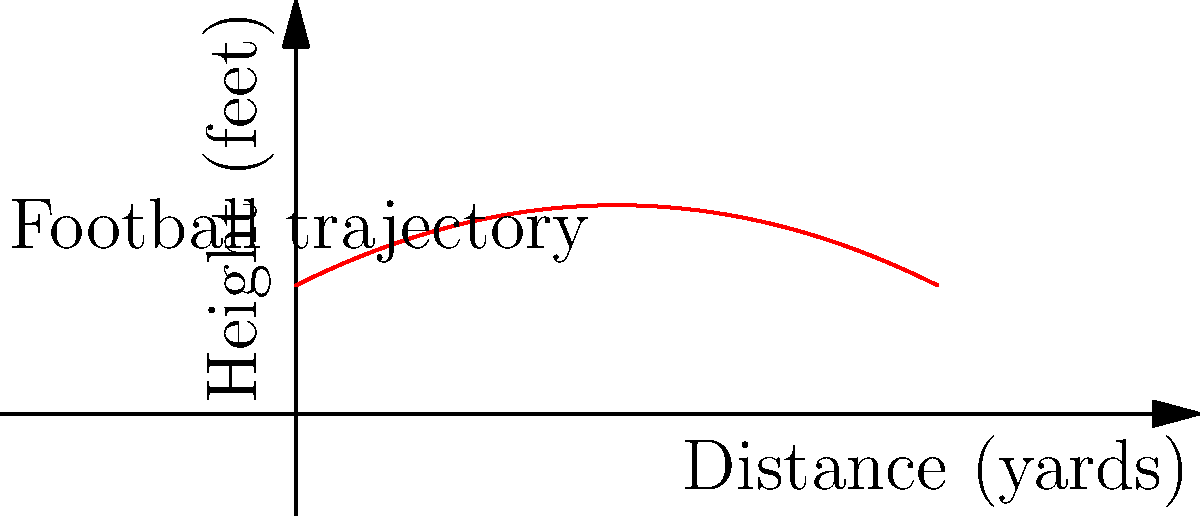As a 49ers fan watching a game, you notice a quarterback's long pass follows a path similar to the curve shown in the graph. Which degree polynomial best describes this trajectory, and what physical factor primarily influences this shape? Let's break this down step-by-step:

1. The curve shown in the graph resembles a parabola, which is the graph of a quadratic function.

2. A quadratic function is a polynomial of degree 2, with the general form $f(x) = ax^2 + bx + c$, where $a$, $b$, and $c$ are constants and $a \neq 0$.

3. In the context of a football pass:
   - The horizontal axis represents the distance traveled by the ball.
   - The vertical axis represents the height of the ball.

4. The shape of this curve is primarily influenced by gravity. As the ball travels forward, gravity constantly pulls it downward, creating the parabolic arc.

5. The equation of the trajectory can be modeled as:

   $h(t) = -\frac{1}{2}gt^2 + v_0\sin(\theta)t + h_0$

   Where:
   - $h$ is the height
   - $t$ is time
   - $g$ is the acceleration due to gravity
   - $v_0$ is the initial velocity
   - $\theta$ is the launch angle
   - $h_0$ is the initial height

6. This equation is indeed a quadratic function in terms of time, which results in the parabolic shape we see in the graph.

Therefore, the trajectory is best described by a polynomial of degree 2 (quadratic), and the primary physical factor influencing this shape is gravity.
Answer: Degree 2 (quadratic); gravity 